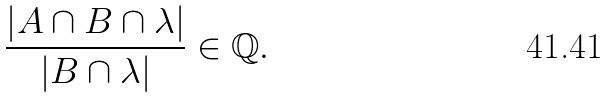Convert formula to latex. <formula><loc_0><loc_0><loc_500><loc_500>\frac { \left | A \cap B \cap \lambda \right | } { \left | B \cap \lambda \right | } \in \mathbb { Q } .</formula> 